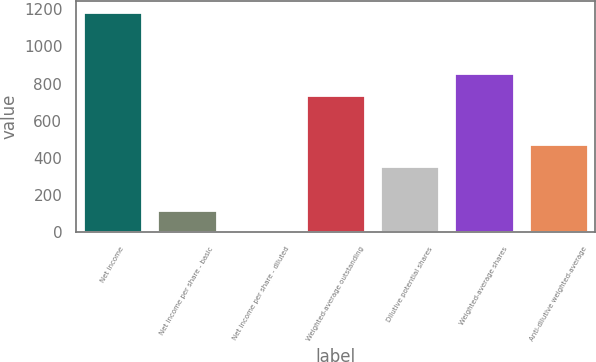Convert chart. <chart><loc_0><loc_0><loc_500><loc_500><bar_chart><fcel>Net income<fcel>Net income per share - basic<fcel>Net income per share - diluted<fcel>Weighted-average outstanding<fcel>Dilutive potential shares<fcel>Weighted-average shares<fcel>Anti-dilutive weighted-average<nl><fcel>1187<fcel>120.13<fcel>1.59<fcel>741<fcel>357.21<fcel>859.54<fcel>475.75<nl></chart> 